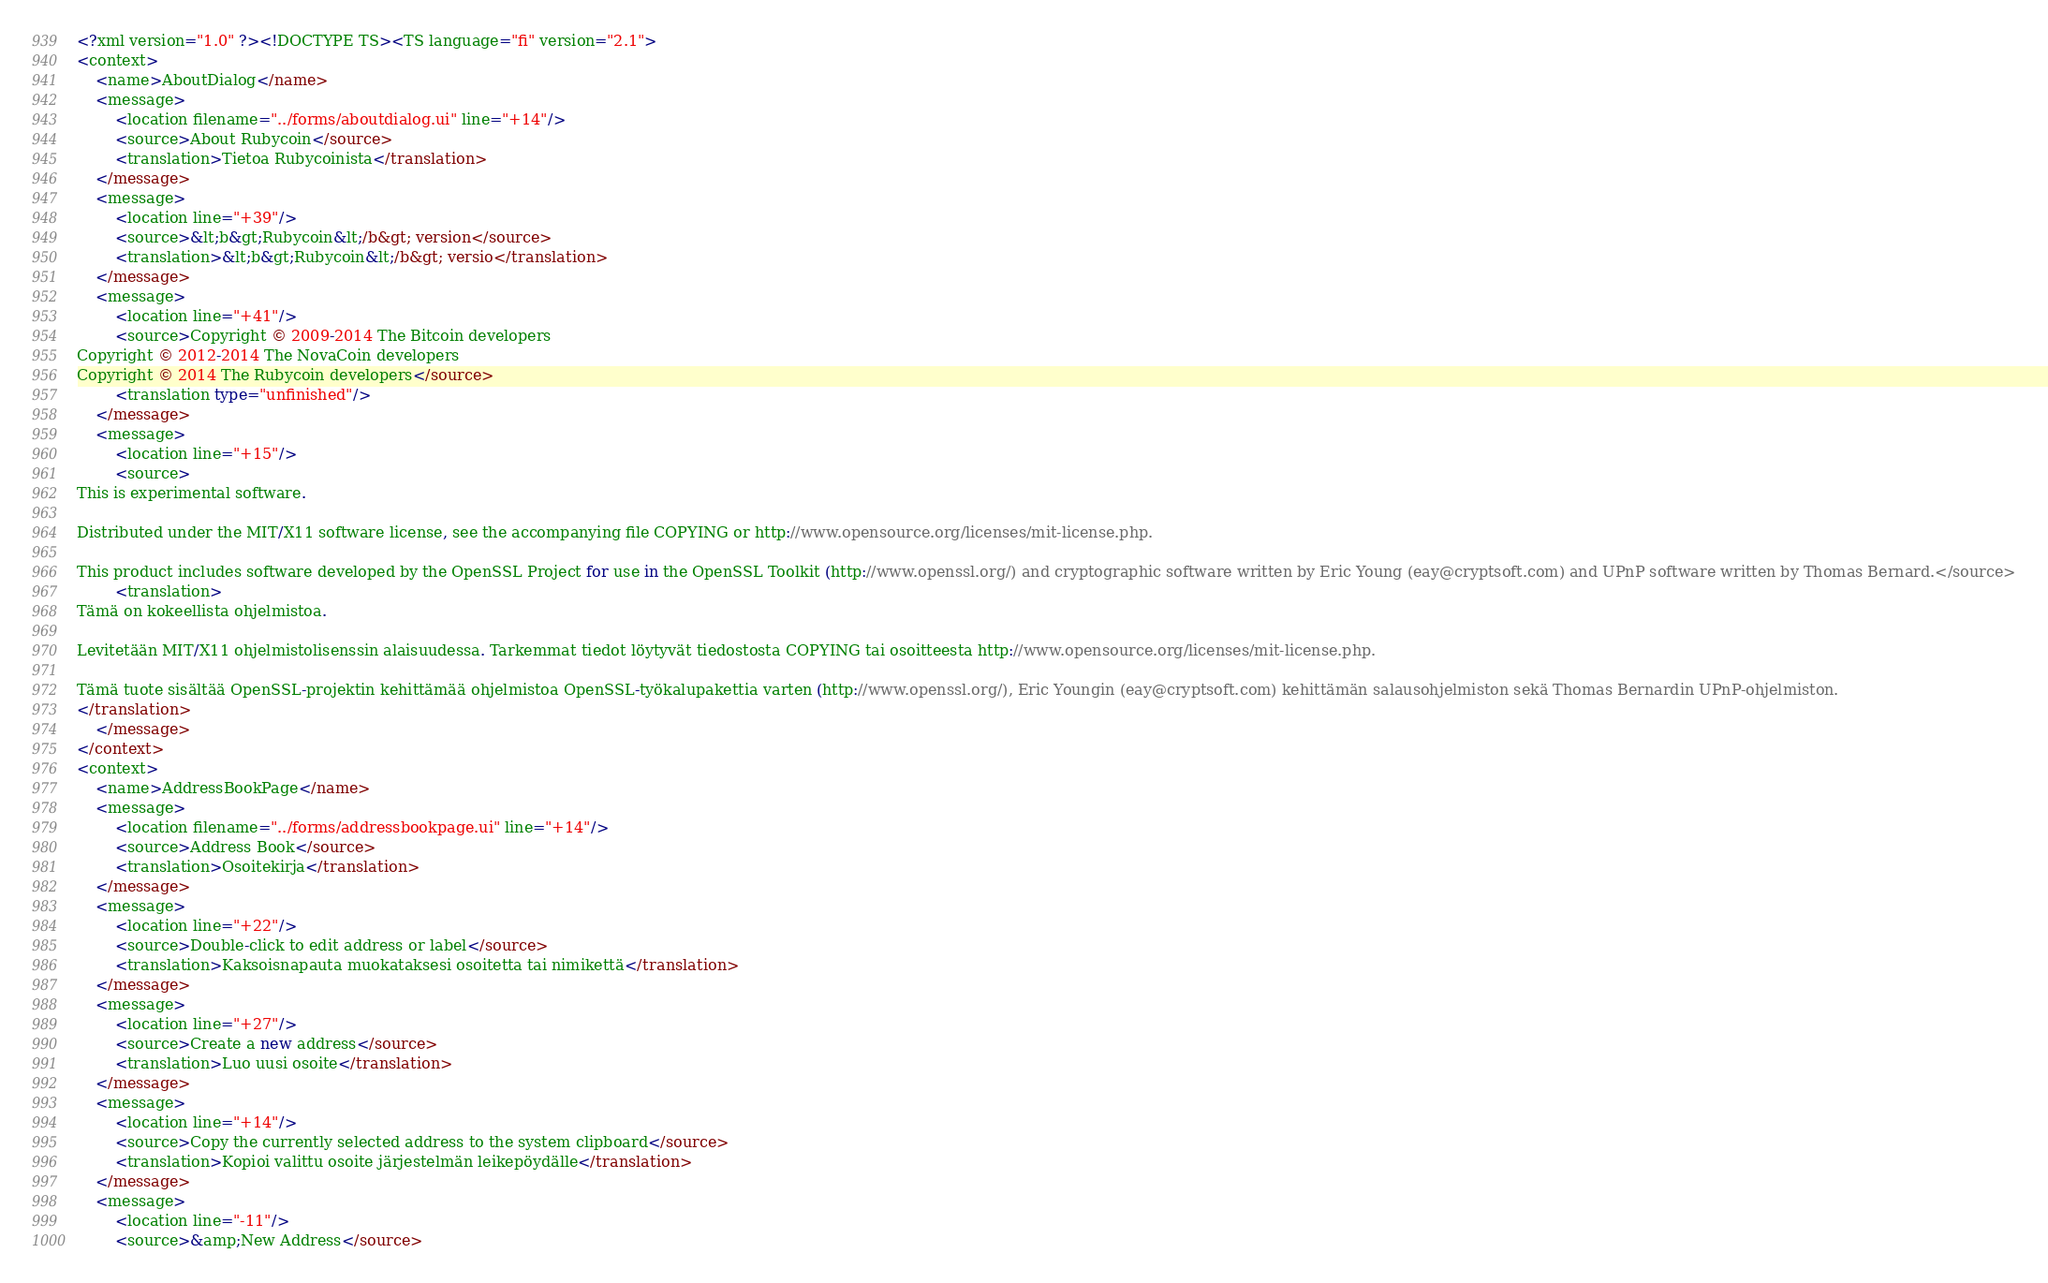Convert code to text. <code><loc_0><loc_0><loc_500><loc_500><_TypeScript_><?xml version="1.0" ?><!DOCTYPE TS><TS language="fi" version="2.1">
<context>
    <name>AboutDialog</name>
    <message>
        <location filename="../forms/aboutdialog.ui" line="+14"/>
        <source>About Rubycoin</source>
        <translation>Tietoa Rubycoinista</translation>
    </message>
    <message>
        <location line="+39"/>
        <source>&lt;b&gt;Rubycoin&lt;/b&gt; version</source>
        <translation>&lt;b&gt;Rubycoin&lt;/b&gt; versio</translation>
    </message>
    <message>
        <location line="+41"/>
        <source>Copyright © 2009-2014 The Bitcoin developers
Copyright © 2012-2014 The NovaCoin developers
Copyright © 2014 The Rubycoin developers</source>
        <translation type="unfinished"/>
    </message>
    <message>
        <location line="+15"/>
        <source>
This is experimental software.

Distributed under the MIT/X11 software license, see the accompanying file COPYING or http://www.opensource.org/licenses/mit-license.php.

This product includes software developed by the OpenSSL Project for use in the OpenSSL Toolkit (http://www.openssl.org/) and cryptographic software written by Eric Young (eay@cryptsoft.com) and UPnP software written by Thomas Bernard.</source>
        <translation>
Tämä on kokeellista ohjelmistoa.

Levitetään MIT/X11 ohjelmistolisenssin alaisuudessa. Tarkemmat tiedot löytyvät tiedostosta COPYING tai osoitteesta http://www.opensource.org/licenses/mit-license.php.

Tämä tuote sisältää OpenSSL-projektin kehittämää ohjelmistoa OpenSSL-työkalupakettia varten (http://www.openssl.org/), Eric Youngin (eay@cryptsoft.com) kehittämän salausohjelmiston sekä Thomas Bernardin UPnP-ohjelmiston.
</translation>
    </message>
</context>
<context>
    <name>AddressBookPage</name>
    <message>
        <location filename="../forms/addressbookpage.ui" line="+14"/>
        <source>Address Book</source>
        <translation>Osoitekirja</translation>
    </message>
    <message>
        <location line="+22"/>
        <source>Double-click to edit address or label</source>
        <translation>Kaksoisnapauta muokataksesi osoitetta tai nimikettä</translation>
    </message>
    <message>
        <location line="+27"/>
        <source>Create a new address</source>
        <translation>Luo uusi osoite</translation>
    </message>
    <message>
        <location line="+14"/>
        <source>Copy the currently selected address to the system clipboard</source>
        <translation>Kopioi valittu osoite järjestelmän leikepöydälle</translation>
    </message>
    <message>
        <location line="-11"/>
        <source>&amp;New Address</source></code> 